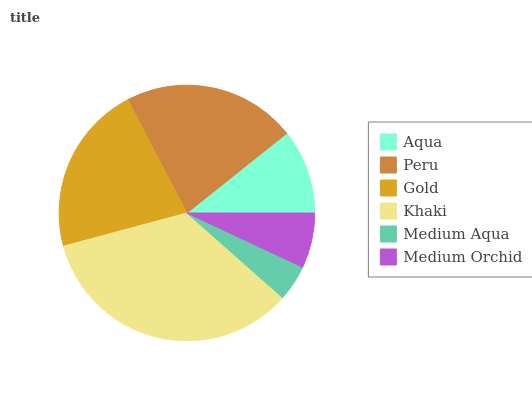Is Medium Aqua the minimum?
Answer yes or no. Yes. Is Khaki the maximum?
Answer yes or no. Yes. Is Peru the minimum?
Answer yes or no. No. Is Peru the maximum?
Answer yes or no. No. Is Peru greater than Aqua?
Answer yes or no. Yes. Is Aqua less than Peru?
Answer yes or no. Yes. Is Aqua greater than Peru?
Answer yes or no. No. Is Peru less than Aqua?
Answer yes or no. No. Is Gold the high median?
Answer yes or no. Yes. Is Aqua the low median?
Answer yes or no. Yes. Is Medium Orchid the high median?
Answer yes or no. No. Is Khaki the low median?
Answer yes or no. No. 